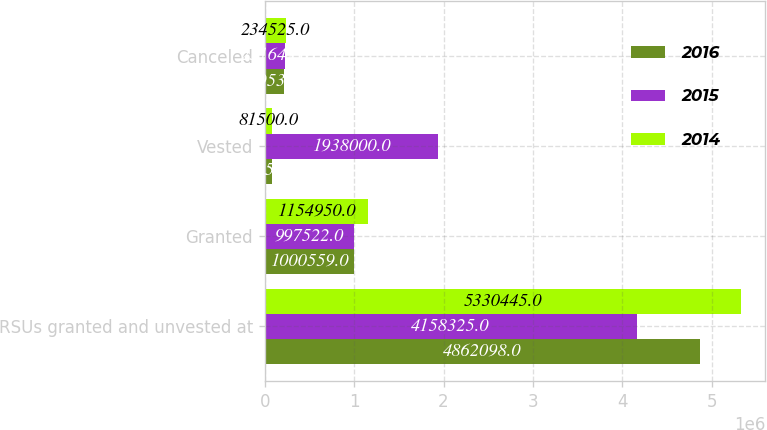<chart> <loc_0><loc_0><loc_500><loc_500><stacked_bar_chart><ecel><fcel>RSUs granted and unvested at<fcel>Granted<fcel>Vested<fcel>Canceled<nl><fcel>2016<fcel>4.8621e+06<fcel>1.00056e+06<fcel>77250<fcel>219536<nl><fcel>2015<fcel>4.15832e+06<fcel>997522<fcel>1.938e+06<fcel>231642<nl><fcel>2014<fcel>5.33044e+06<fcel>1.15495e+06<fcel>81500<fcel>234525<nl></chart> 